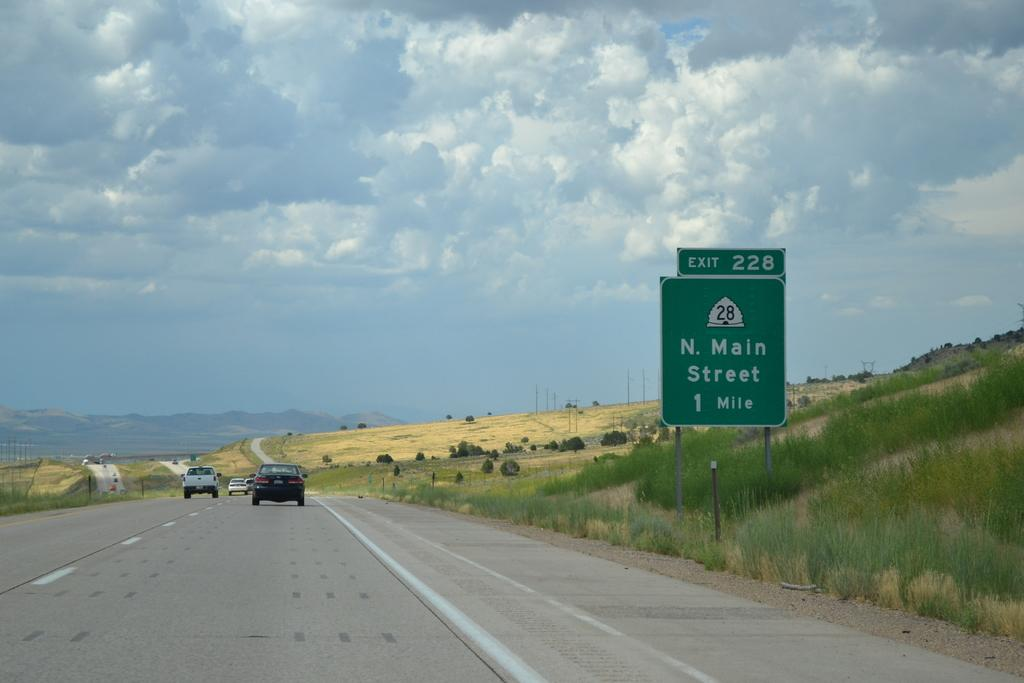Provide a one-sentence caption for the provided image. The sign on the freeway indicates that the N. Main Street exit is in one mile ahead. 